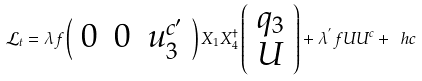Convert formula to latex. <formula><loc_0><loc_0><loc_500><loc_500>\mathcal { L } _ { t } = \lambda f \left ( \begin{array} { c c c } 0 & 0 & u _ { 3 } ^ { c ^ { \prime } } \end{array} \right ) X _ { 1 } X _ { 4 } ^ { \dag } \left ( \begin{array} { c } q _ { 3 } \\ U \end{array} \right ) + \lambda ^ { ^ { \prime } } f U U ^ { c } + \ h c</formula> 